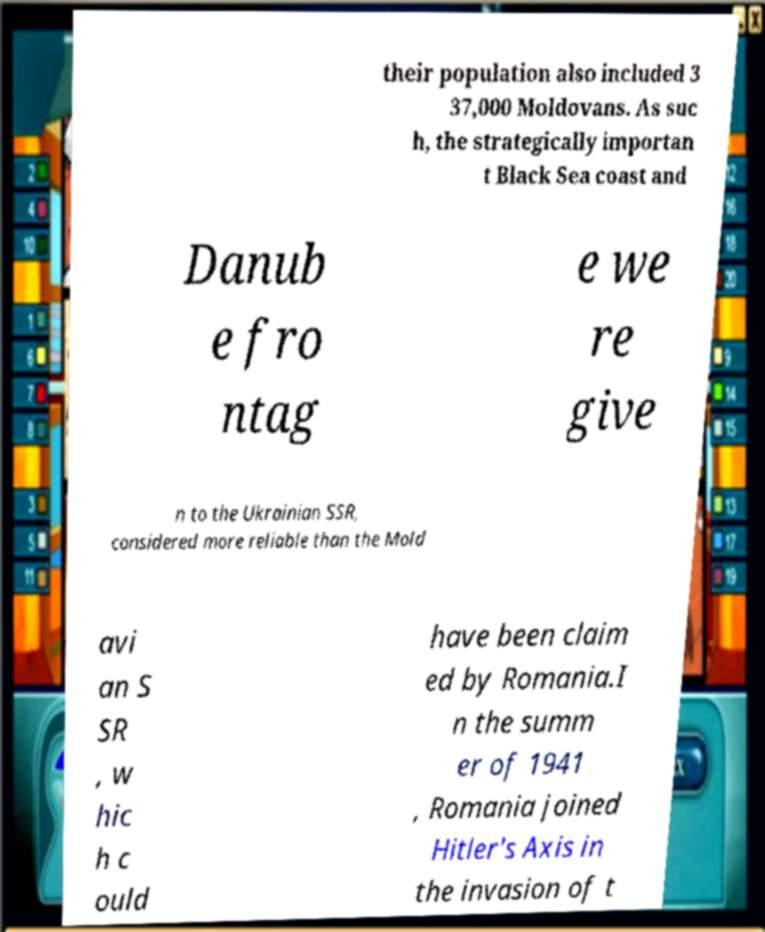Can you accurately transcribe the text from the provided image for me? their population also included 3 37,000 Moldovans. As suc h, the strategically importan t Black Sea coast and Danub e fro ntag e we re give n to the Ukrainian SSR, considered more reliable than the Mold avi an S SR , w hic h c ould have been claim ed by Romania.I n the summ er of 1941 , Romania joined Hitler's Axis in the invasion of t 